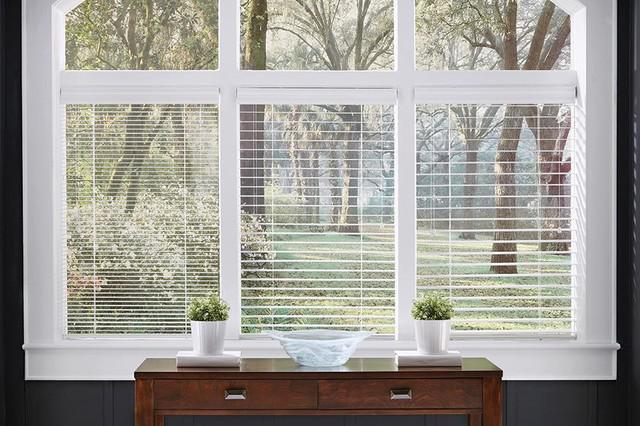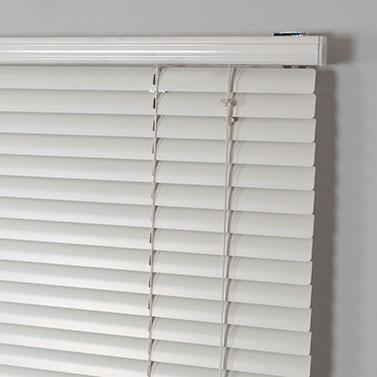The first image is the image on the left, the second image is the image on the right. Considering the images on both sides, is "At least two shades are partially pulled up." valid? Answer yes or no. No. The first image is the image on the left, the second image is the image on the right. Examine the images to the left and right. Is the description "There are a total of four blinds." accurate? Answer yes or no. Yes. 